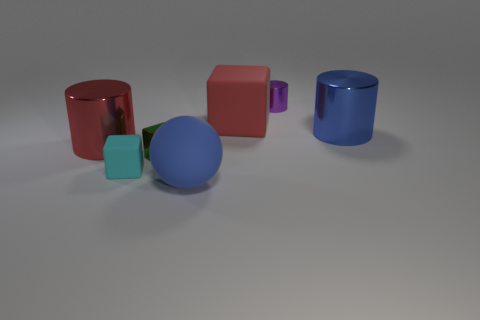Are there an equal number of big blocks that are right of the blue metallic thing and small cyan metallic spheres?
Make the answer very short. Yes. What size is the blue object that is right of the tiny cylinder?
Offer a very short reply. Large. How many big objects are red cylinders or matte balls?
Make the answer very short. 2. What is the color of the shiny object that is the same shape as the red matte object?
Offer a very short reply. Green. Does the cyan cube have the same size as the purple cylinder?
Your answer should be very brief. Yes. What number of things are either tiny shiny cylinders or cylinders right of the large red rubber block?
Your response must be concise. 2. There is a matte cube behind the big blue thing behind the matte sphere; what is its color?
Give a very brief answer. Red. Does the shiny cylinder left of the small cylinder have the same color as the tiny metallic cylinder?
Give a very brief answer. No. What material is the big red object to the right of the blue rubber ball?
Offer a very short reply. Rubber. The blue cylinder has what size?
Ensure brevity in your answer.  Large. 